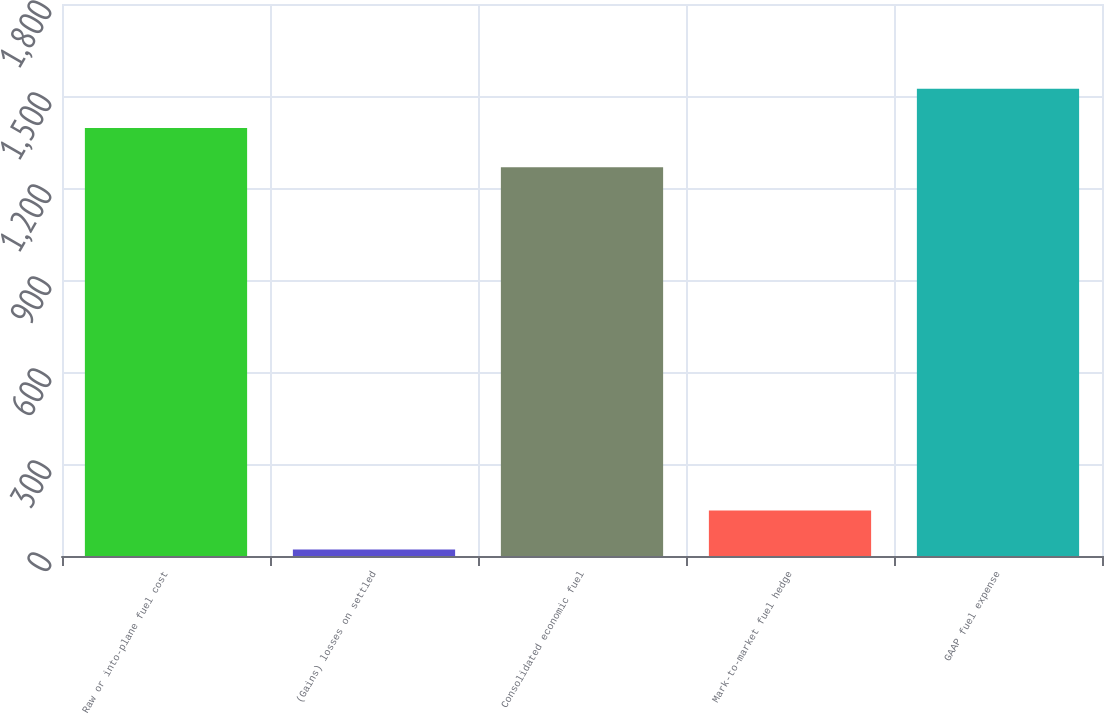Convert chart to OTSL. <chart><loc_0><loc_0><loc_500><loc_500><bar_chart><fcel>Raw or into-plane fuel cost<fcel>(Gains) losses on settled<fcel>Consolidated economic fuel<fcel>Mark-to-market fuel hedge<fcel>GAAP fuel expense<nl><fcel>1395.7<fcel>21<fcel>1268<fcel>148.7<fcel>1523.4<nl></chart> 